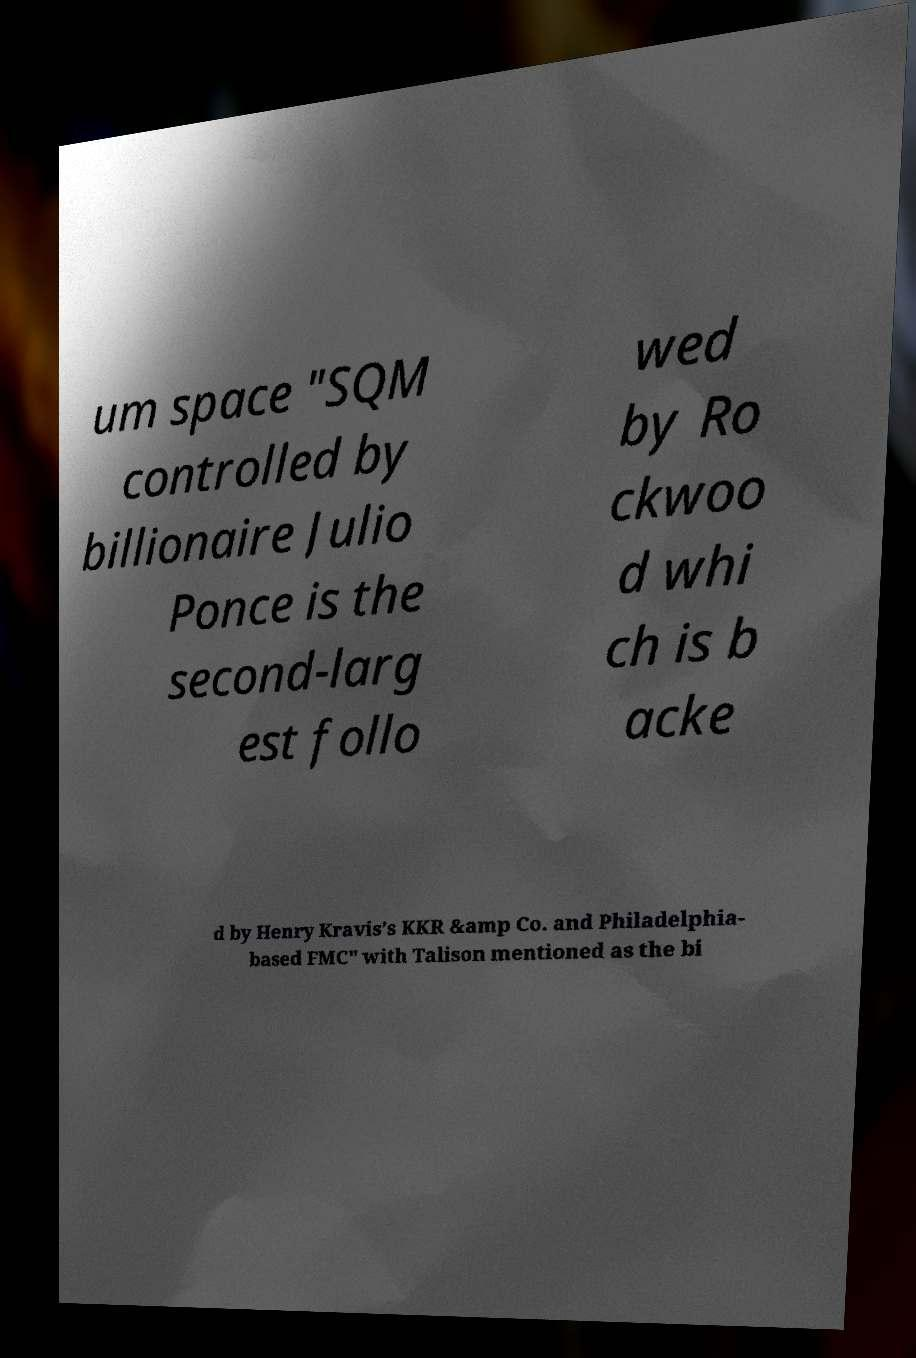Can you accurately transcribe the text from the provided image for me? um space "SQM controlled by billionaire Julio Ponce is the second-larg est follo wed by Ro ckwoo d whi ch is b acke d by Henry Kravis’s KKR &amp Co. and Philadelphia- based FMC" with Talison mentioned as the bi 